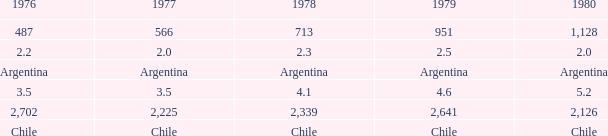What is 1976 when 1977 is 3.5? 3.5. 